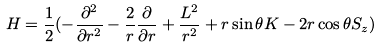Convert formula to latex. <formula><loc_0><loc_0><loc_500><loc_500>H = \frac { 1 } { 2 } ( - \frac { \partial ^ { 2 } } { \partial r ^ { 2 } } - \frac { 2 } { r } \frac { \partial } { \partial r } + \frac { L ^ { 2 } } { r ^ { 2 } } + r \sin \theta K - 2 r \cos \theta S _ { z } )</formula> 